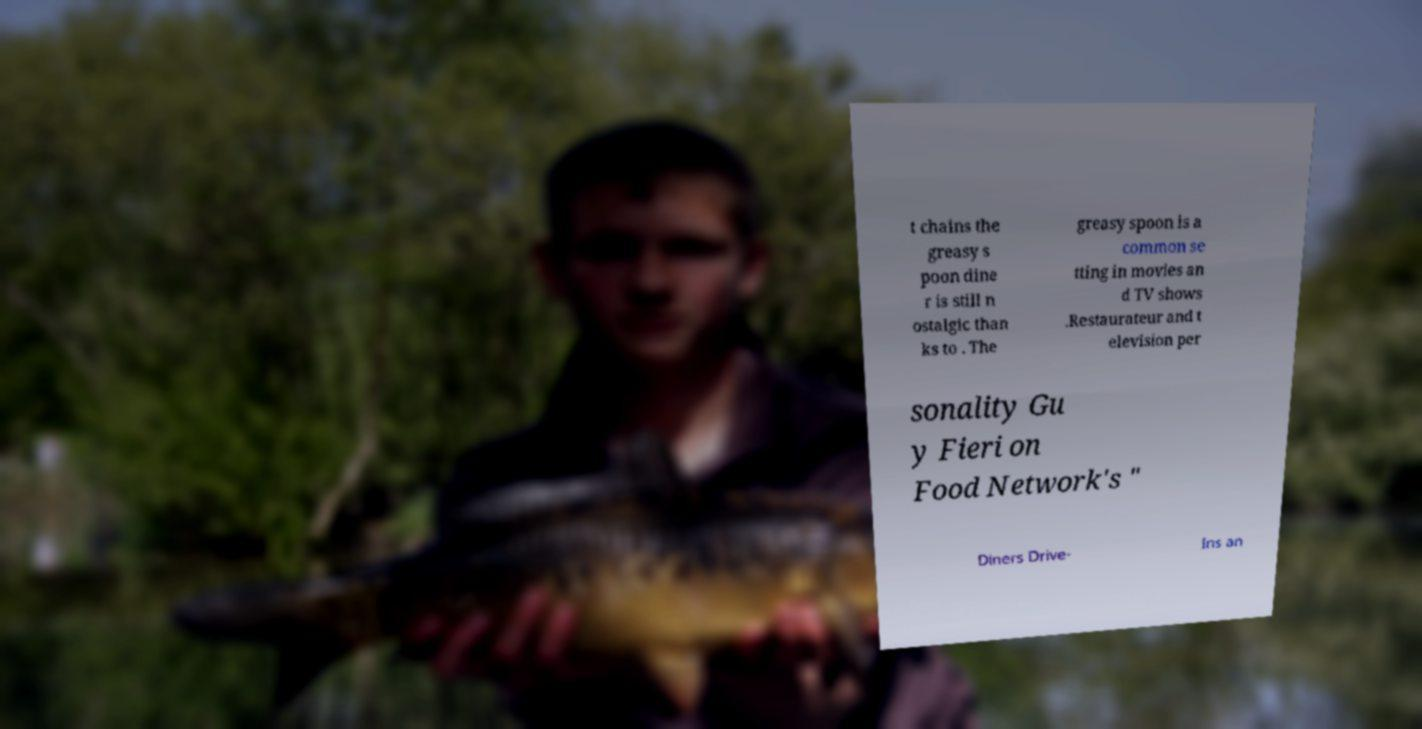For documentation purposes, I need the text within this image transcribed. Could you provide that? t chains the greasy s poon dine r is still n ostalgic than ks to . The greasy spoon is a common se tting in movies an d TV shows .Restaurateur and t elevision per sonality Gu y Fieri on Food Network's " Diners Drive- Ins an 